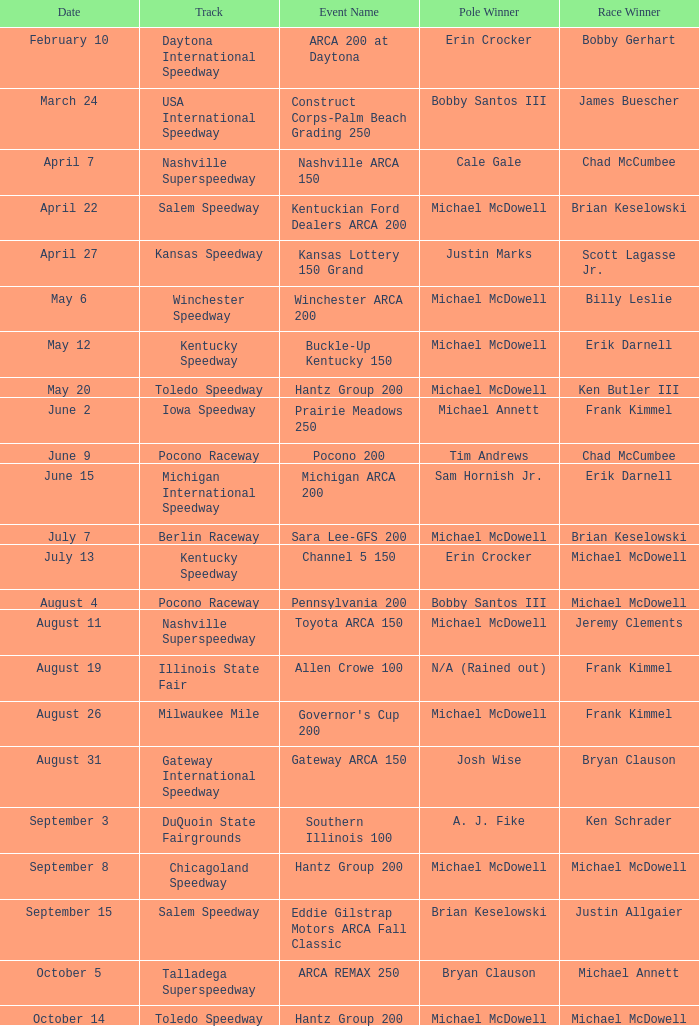Can you parse all the data within this table? {'header': ['Date', 'Track', 'Event Name', 'Pole Winner', 'Race Winner'], 'rows': [['February 10', 'Daytona International Speedway', 'ARCA 200 at Daytona', 'Erin Crocker', 'Bobby Gerhart'], ['March 24', 'USA International Speedway', 'Construct Corps-Palm Beach Grading 250', 'Bobby Santos III', 'James Buescher'], ['April 7', 'Nashville Superspeedway', 'Nashville ARCA 150', 'Cale Gale', 'Chad McCumbee'], ['April 22', 'Salem Speedway', 'Kentuckian Ford Dealers ARCA 200', 'Michael McDowell', 'Brian Keselowski'], ['April 27', 'Kansas Speedway', 'Kansas Lottery 150 Grand', 'Justin Marks', 'Scott Lagasse Jr.'], ['May 6', 'Winchester Speedway', 'Winchester ARCA 200', 'Michael McDowell', 'Billy Leslie'], ['May 12', 'Kentucky Speedway', 'Buckle-Up Kentucky 150', 'Michael McDowell', 'Erik Darnell'], ['May 20', 'Toledo Speedway', 'Hantz Group 200', 'Michael McDowell', 'Ken Butler III'], ['June 2', 'Iowa Speedway', 'Prairie Meadows 250', 'Michael Annett', 'Frank Kimmel'], ['June 9', 'Pocono Raceway', 'Pocono 200', 'Tim Andrews', 'Chad McCumbee'], ['June 15', 'Michigan International Speedway', 'Michigan ARCA 200', 'Sam Hornish Jr.', 'Erik Darnell'], ['July 7', 'Berlin Raceway', 'Sara Lee-GFS 200', 'Michael McDowell', 'Brian Keselowski'], ['July 13', 'Kentucky Speedway', 'Channel 5 150', 'Erin Crocker', 'Michael McDowell'], ['August 4', 'Pocono Raceway', 'Pennsylvania 200', 'Bobby Santos III', 'Michael McDowell'], ['August 11', 'Nashville Superspeedway', 'Toyota ARCA 150', 'Michael McDowell', 'Jeremy Clements'], ['August 19', 'Illinois State Fair', 'Allen Crowe 100', 'N/A (Rained out)', 'Frank Kimmel'], ['August 26', 'Milwaukee Mile', "Governor's Cup 200", 'Michael McDowell', 'Frank Kimmel'], ['August 31', 'Gateway International Speedway', 'Gateway ARCA 150', 'Josh Wise', 'Bryan Clauson'], ['September 3', 'DuQuoin State Fairgrounds', 'Southern Illinois 100', 'A. J. Fike', 'Ken Schrader'], ['September 8', 'Chicagoland Speedway', 'Hantz Group 200', 'Michael McDowell', 'Michael McDowell'], ['September 15', 'Salem Speedway', 'Eddie Gilstrap Motors ARCA Fall Classic', 'Brian Keselowski', 'Justin Allgaier'], ['October 5', 'Talladega Superspeedway', 'ARCA REMAX 250', 'Bryan Clauson', 'Michael Annett'], ['October 14', 'Toledo Speedway', 'Hantz Group 200', 'Michael McDowell', 'Michael McDowell']]} Who is the pole triumph-holder on may 12? Michael McDowell. 